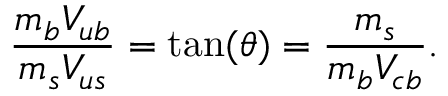Convert formula to latex. <formula><loc_0><loc_0><loc_500><loc_500>{ \frac { m _ { b } V _ { u b } } { m _ { s } V _ { u s } } } = t a n ( \theta ) = { \frac { m _ { s } } { m _ { b } V _ { c b } } } .</formula> 